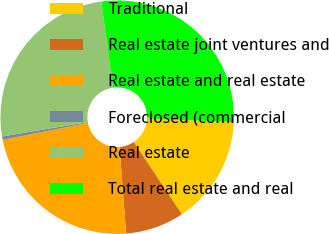Convert chart. <chart><loc_0><loc_0><loc_500><loc_500><pie_chart><fcel>Traditional<fcel>Real estate joint ventures and<fcel>Real estate and real estate<fcel>Foreclosed (commercial<fcel>Real estate<fcel>Total real estate and real<nl><fcel>14.98%<fcel>8.13%<fcel>23.11%<fcel>0.46%<fcel>25.48%<fcel>27.84%<nl></chart> 